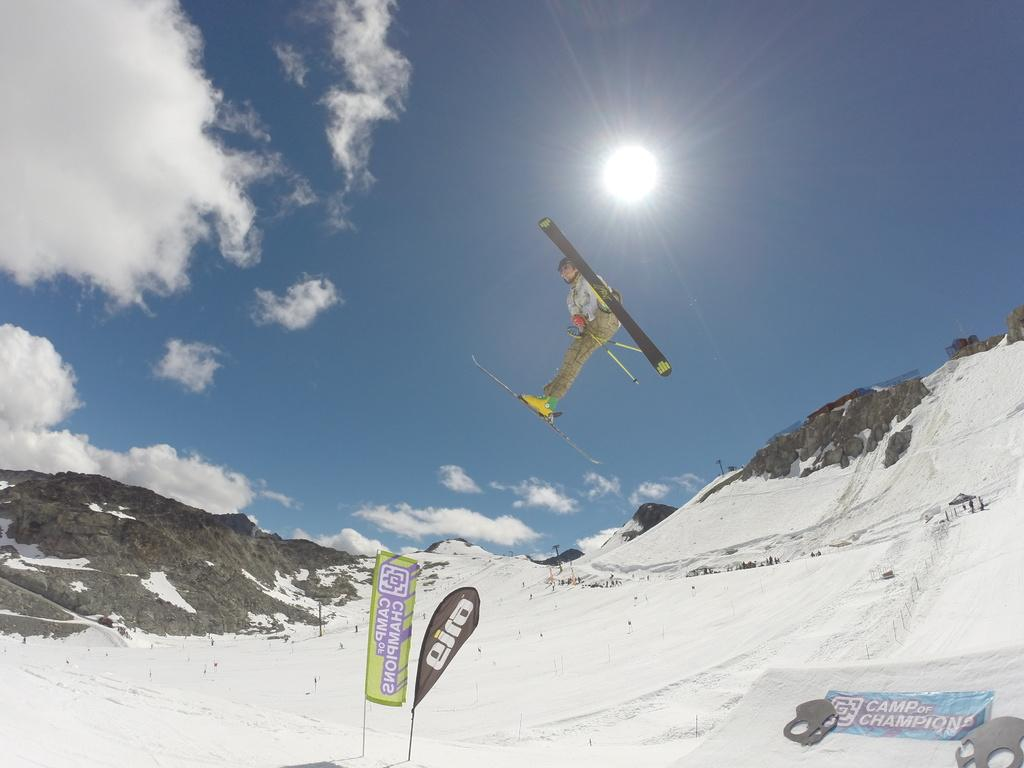What is the person in the image doing? The person is jumping in the air. What type of footwear is the person wearing? The person is wearing skates. What is the environment like in the image? The setting is in the snow. What is visible in the sky in the image? The sun is visible at the top of the image, and there are clouds in the sky. Can you see a cub playing in the snow in the image? There is no cub present in the image; it features a person wearing skates and jumping in the air. Is the person seeking approval from someone in the image? There is no indication in the image that the person is seeking approval from anyone. 